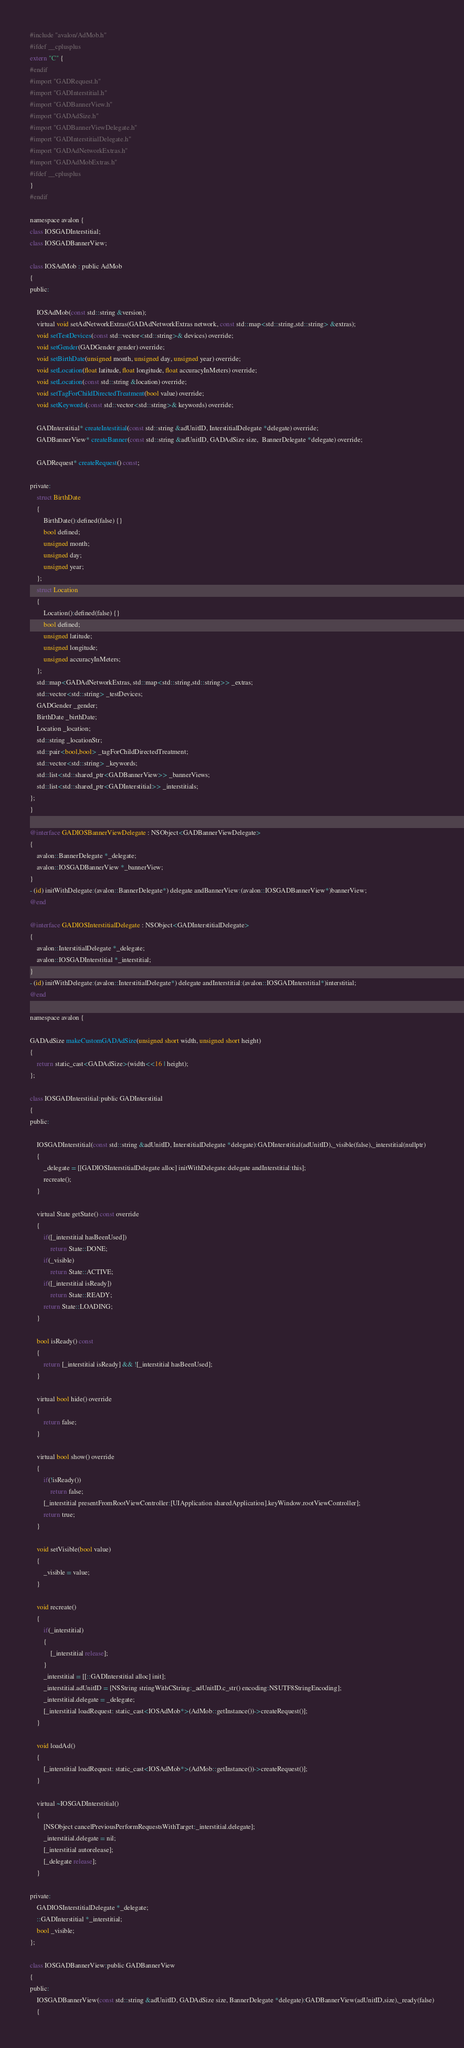Convert code to text. <code><loc_0><loc_0><loc_500><loc_500><_ObjectiveC_>#include "avalon/AdMob.h"
#ifdef __cplusplus
extern "C" {
#endif
#import "GADRequest.h"
#import "GADInterstitial.h"
#import "GADBannerView.h"
#import "GADAdSize.h"
#import "GADBannerViewDelegate.h"
#import "GADInterstitialDelegate.h"
#import "GADAdNetworkExtras.h"
#import "GADAdMobExtras.h"
#ifdef __cplusplus
}
#endif

namespace avalon {
class IOSGADInterstitial;
class IOSGADBannerView;
    
class IOSAdMob : public AdMob
{
public:
    
    IOSAdMob(const std::string &version);
    virtual void setAdNetworkExtras(GADAdNetworkExtras network, const std::map<std::string,std::string> &extras);
    void setTestDevices(const std::vector<std::string>& devices) override;
    void setGender(GADGender gender) override;
    void setBirthDate(unsigned month, unsigned day, unsigned year) override;
    void setLocation(float latitude, float longitude, float accuracyInMeters) override;
    void setLocation(const std::string &location) override;
    void setTagForChildDirectedTreatment(bool value) override;
    void setKeywords(const std::vector<std::string>& keywords) override;
    
    GADInterstitial* createIntestitial(const std::string &adUnitID, InterstitialDelegate *delegate) override;
    GADBannerView* createBanner(const std::string &adUnitID, GADAdSize size,  BannerDelegate *delegate) override;
    
    GADRequest* createRequest() const;
    
private:
    struct BirthDate
    {
        BirthDate():defined(false) {}
        bool defined;
        unsigned month;
        unsigned day;
        unsigned year;
    };
    struct Location
    {
        Location():defined(false) {}
        bool defined;
        unsigned latitude;
        unsigned longitude;
        unsigned accuracyInMeters;
    };
    std::map<GADAdNetworkExtras, std::map<std::string,std::string>> _extras;
    std::vector<std::string> _testDevices;
    GADGender _gender;
    BirthDate _birthDate;
    Location _location;
    std::string _locationStr;
    std::pair<bool,bool> _tagForChildDirectedTreatment;
    std::vector<std::string> _keywords;
    std::list<std::shared_ptr<GADBannerView>> _bannerViews;
    std::list<std::shared_ptr<GADInterstitial>> _interstitials;
};
}

@interface GADIOSBannerViewDelegate : NSObject<GADBannerViewDelegate>
{
    avalon::BannerDelegate *_delegate;
    avalon::IOSGADBannerView *_bannerView;
}
- (id) initWithDelegate:(avalon::BannerDelegate*) delegate andBannerView:(avalon::IOSGADBannerView*)bannerView;
@end

@interface GADIOSInterstitialDelegate : NSObject<GADInterstitialDelegate>
{
    avalon::InterstitialDelegate *_delegate;
    avalon::IOSGADInterstitial *_interstitial;
}
- (id) initWithDelegate:(avalon::InterstitialDelegate*) delegate andInterstitial:(avalon::IOSGADInterstitial*)interstitial;
@end

namespace avalon {
    
GADAdSize makeCustomGADAdSize(unsigned short width, unsigned short height)
{
    return static_cast<GADAdSize>(width<<16 | height);
};
    
class IOSGADInterstitial:public GADInterstitial
{
public:
    
    IOSGADInterstitial(const std::string &adUnitID, InterstitialDelegate *delegate):GADInterstitial(adUnitID),_visible(false),_interstitial(nullptr)
    {
        _delegate = [[GADIOSInterstitialDelegate alloc] initWithDelegate:delegate andInterstitial:this];
        recreate();
    }
    
    virtual State getState() const override
    {
        if([_interstitial hasBeenUsed])
            return State::DONE;
        if(_visible)
            return State::ACTIVE;
        if([_interstitial isReady])
            return State::READY;
        return State::LOADING;
    }
    
    bool isReady() const
    {
        return [_interstitial isReady] && ![_interstitial hasBeenUsed];
    }
    
    virtual bool hide() override
    {
        return false;
    }
    
    virtual bool show() override
    {
        if(!isReady())
            return false;
        [_interstitial presentFromRootViewController:[UIApplication sharedApplication].keyWindow.rootViewController];
        return true;
    }
    
    void setVisible(bool value)
    {
        _visible = value;
    }
    
    void recreate()
    {
        if(_interstitial)
        {
            [_interstitial release];
        }
        _interstitial = [[::GADInterstitial alloc] init];
        _interstitial.adUnitID = [NSString stringWithCString:_adUnitID.c_str() encoding:NSUTF8StringEncoding];
        _interstitial.delegate = _delegate;
        [_interstitial loadRequest: static_cast<IOSAdMob*>(AdMob::getInstance())->createRequest()];
    }
    
    void loadAd()
    {
        [_interstitial loadRequest: static_cast<IOSAdMob*>(AdMob::getInstance())->createRequest()];
    }
    
    virtual ~IOSGADInterstitial()
    {
        [NSObject cancelPreviousPerformRequestsWithTarget:_interstitial.delegate];
        _interstitial.delegate = nil;
        [_interstitial autorelease];
        [_delegate release];
    }
    
private:
    GADIOSInterstitialDelegate *_delegate;
    ::GADInterstitial *_interstitial;
    bool _visible;
};
    
class IOSGADBannerView:public GADBannerView
{
public:
    IOSGADBannerView(const std::string &adUnitID, GADAdSize size, BannerDelegate *delegate):GADBannerView(adUnitID,size),_ready(false)
    {</code> 